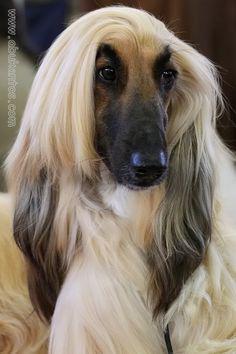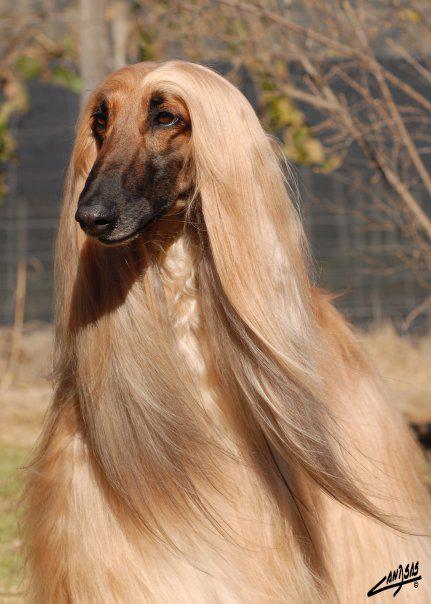The first image is the image on the left, the second image is the image on the right. Analyze the images presented: Is the assertion "All images contain afghan dogs with black snouts." valid? Answer yes or no. Yes. The first image is the image on the left, the second image is the image on the right. Examine the images to the left and right. Is the description "The hound on the right has reddish fur on its muzzle instead of a dark muzzle, and blonde hair on top of its head parted down the middle." accurate? Answer yes or no. No. 